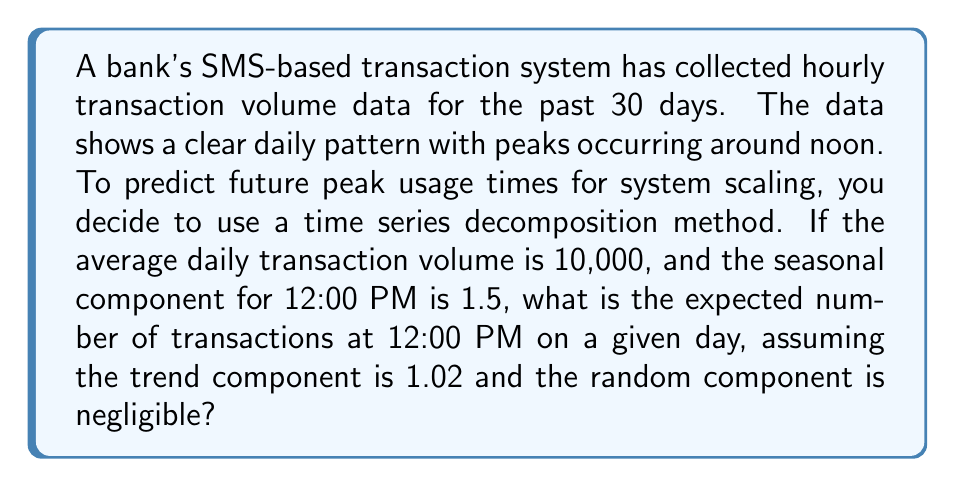Can you solve this math problem? To solve this problem, we need to understand the components of time series decomposition and how they interact. The multiplicative time series model is given by:

$$ Y_t = T_t \times S_t \times R_t $$

Where:
- $Y_t$ is the observed value at time $t$
- $T_t$ is the trend component
- $S_t$ is the seasonal component
- $R_t$ is the random component

Given:
- Average daily transaction volume: 10,000
- Seasonal component at 12:00 PM: $S_t = 1.5$
- Trend component: $T_t = 1.02$
- Random component: negligible (assume $R_t = 1$)

Steps to solve:

1. Calculate the average hourly transaction volume:
   $$ \text{Hourly average} = \frac{\text{Daily average}}{24} = \frac{10,000}{24} \approx 416.67 $$

2. Apply the time series decomposition model:
   $$ Y_t = 416.67 \times 1.02 \times 1.5 \times 1 $$

3. Calculate the expected number of transactions:
   $$ Y_t = 416.67 \times 1.02 \times 1.5 = 637.5051 $$

4. Round to the nearest whole number, as we can't have fractional transactions:
   $$ Y_t \approx 638 $$

Therefore, the expected number of transactions at 12:00 PM on a given day is 638.
Answer: 638 transactions 